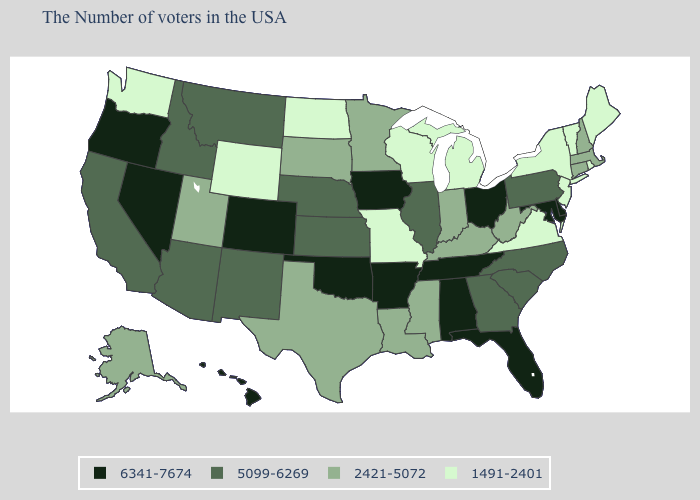What is the value of Ohio?
Keep it brief. 6341-7674. Name the states that have a value in the range 2421-5072?
Write a very short answer. Massachusetts, New Hampshire, Connecticut, West Virginia, Kentucky, Indiana, Mississippi, Louisiana, Minnesota, Texas, South Dakota, Utah, Alaska. Does the first symbol in the legend represent the smallest category?
Give a very brief answer. No. What is the value of Arkansas?
Concise answer only. 6341-7674. How many symbols are there in the legend?
Quick response, please. 4. Does Nebraska have the highest value in the MidWest?
Give a very brief answer. No. Does Wisconsin have the lowest value in the USA?
Concise answer only. Yes. What is the lowest value in states that border Pennsylvania?
Be succinct. 1491-2401. Among the states that border North Dakota , which have the lowest value?
Write a very short answer. Minnesota, South Dakota. Which states have the lowest value in the West?
Answer briefly. Wyoming, Washington. Name the states that have a value in the range 5099-6269?
Quick response, please. Pennsylvania, North Carolina, South Carolina, Georgia, Illinois, Kansas, Nebraska, New Mexico, Montana, Arizona, Idaho, California. Does Wyoming have the lowest value in the West?
Give a very brief answer. Yes. Name the states that have a value in the range 1491-2401?
Keep it brief. Maine, Rhode Island, Vermont, New York, New Jersey, Virginia, Michigan, Wisconsin, Missouri, North Dakota, Wyoming, Washington. Name the states that have a value in the range 5099-6269?
Answer briefly. Pennsylvania, North Carolina, South Carolina, Georgia, Illinois, Kansas, Nebraska, New Mexico, Montana, Arizona, Idaho, California. Does Washington have the same value as Wisconsin?
Give a very brief answer. Yes. 